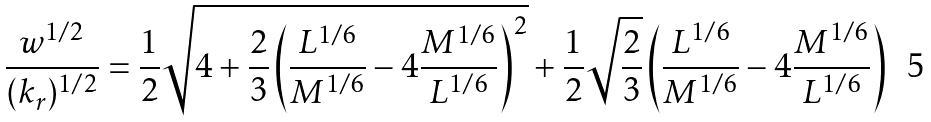Convert formula to latex. <formula><loc_0><loc_0><loc_500><loc_500>\frac { w ^ { 1 / 2 } } { ( k _ { r } ) ^ { 1 / 2 } } = \frac { 1 } { 2 } \sqrt { 4 + \frac { 2 } { 3 } \left ( \frac { L ^ { 1 / 6 } } { M ^ { 1 / 6 } } - 4 \frac { M ^ { 1 / 6 } } { L ^ { 1 / 6 } } \right ) ^ { 2 } } + \frac { 1 } { 2 } \sqrt { \frac { 2 } { 3 } } \left ( \frac { L ^ { 1 / 6 } } { M ^ { 1 / 6 } } - 4 \frac { M ^ { 1 / 6 } } { L ^ { 1 / 6 } } \right )</formula> 